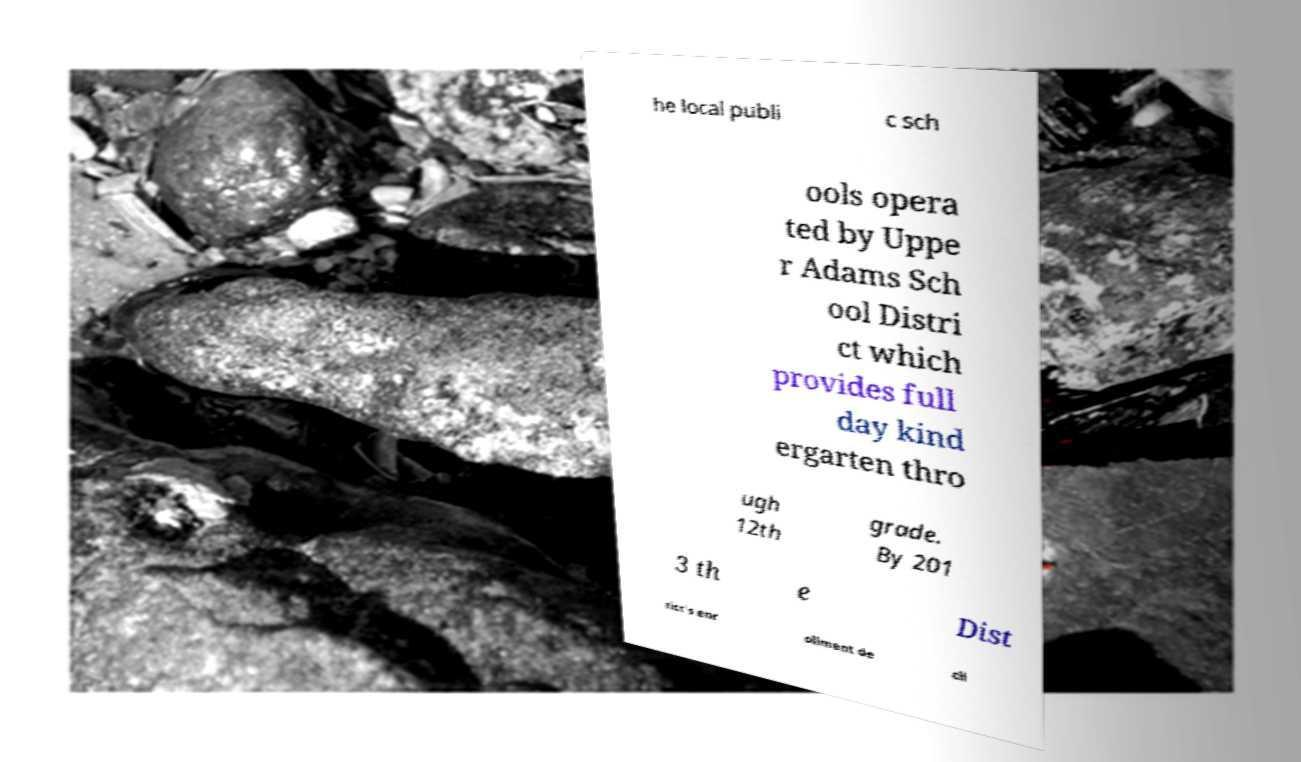Can you read and provide the text displayed in the image?This photo seems to have some interesting text. Can you extract and type it out for me? he local publi c sch ools opera ted by Uppe r Adams Sch ool Distri ct which provides full day kind ergarten thro ugh 12th grade. By 201 3 th e Dist rict's enr ollment de cli 